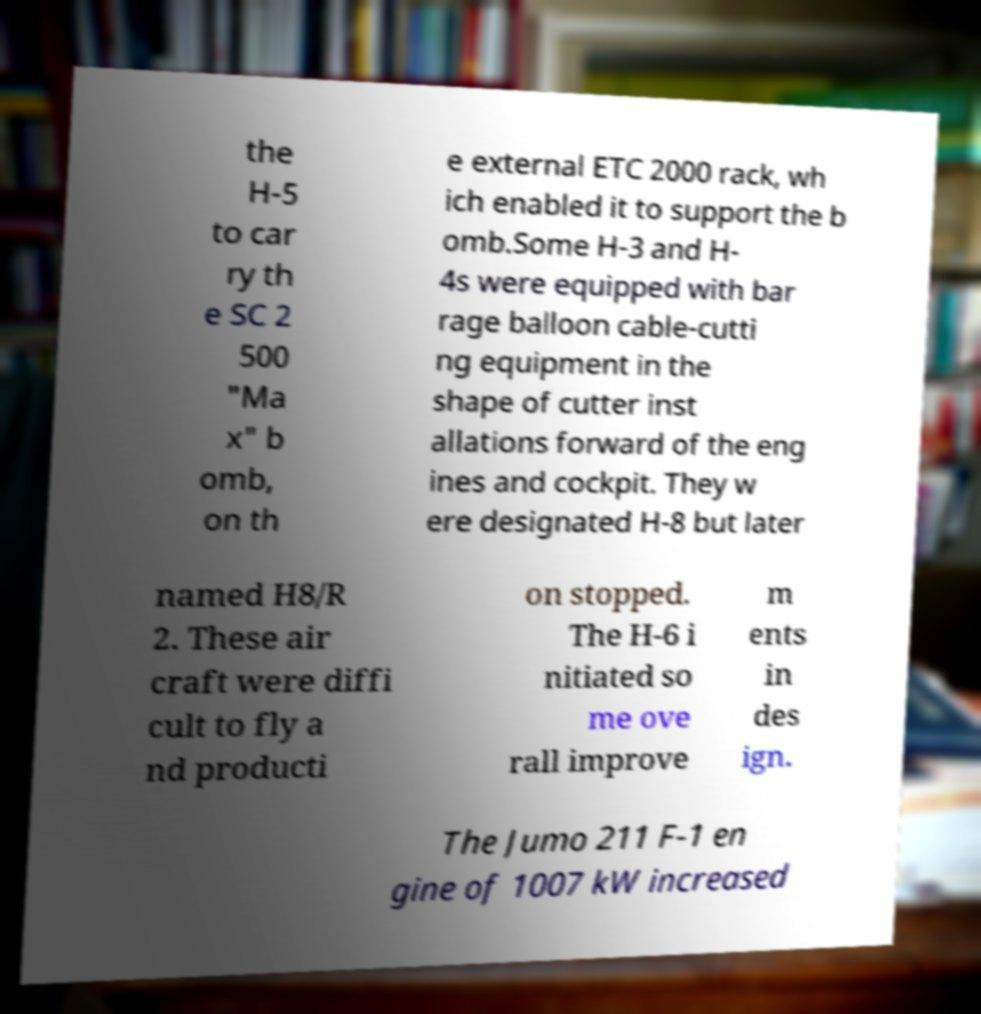I need the written content from this picture converted into text. Can you do that? the H-5 to car ry th e SC 2 500 "Ma x" b omb, on th e external ETC 2000 rack, wh ich enabled it to support the b omb.Some H-3 and H- 4s were equipped with bar rage balloon cable-cutti ng equipment in the shape of cutter inst allations forward of the eng ines and cockpit. They w ere designated H-8 but later named H8/R 2. These air craft were diffi cult to fly a nd producti on stopped. The H-6 i nitiated so me ove rall improve m ents in des ign. The Jumo 211 F-1 en gine of 1007 kW increased 